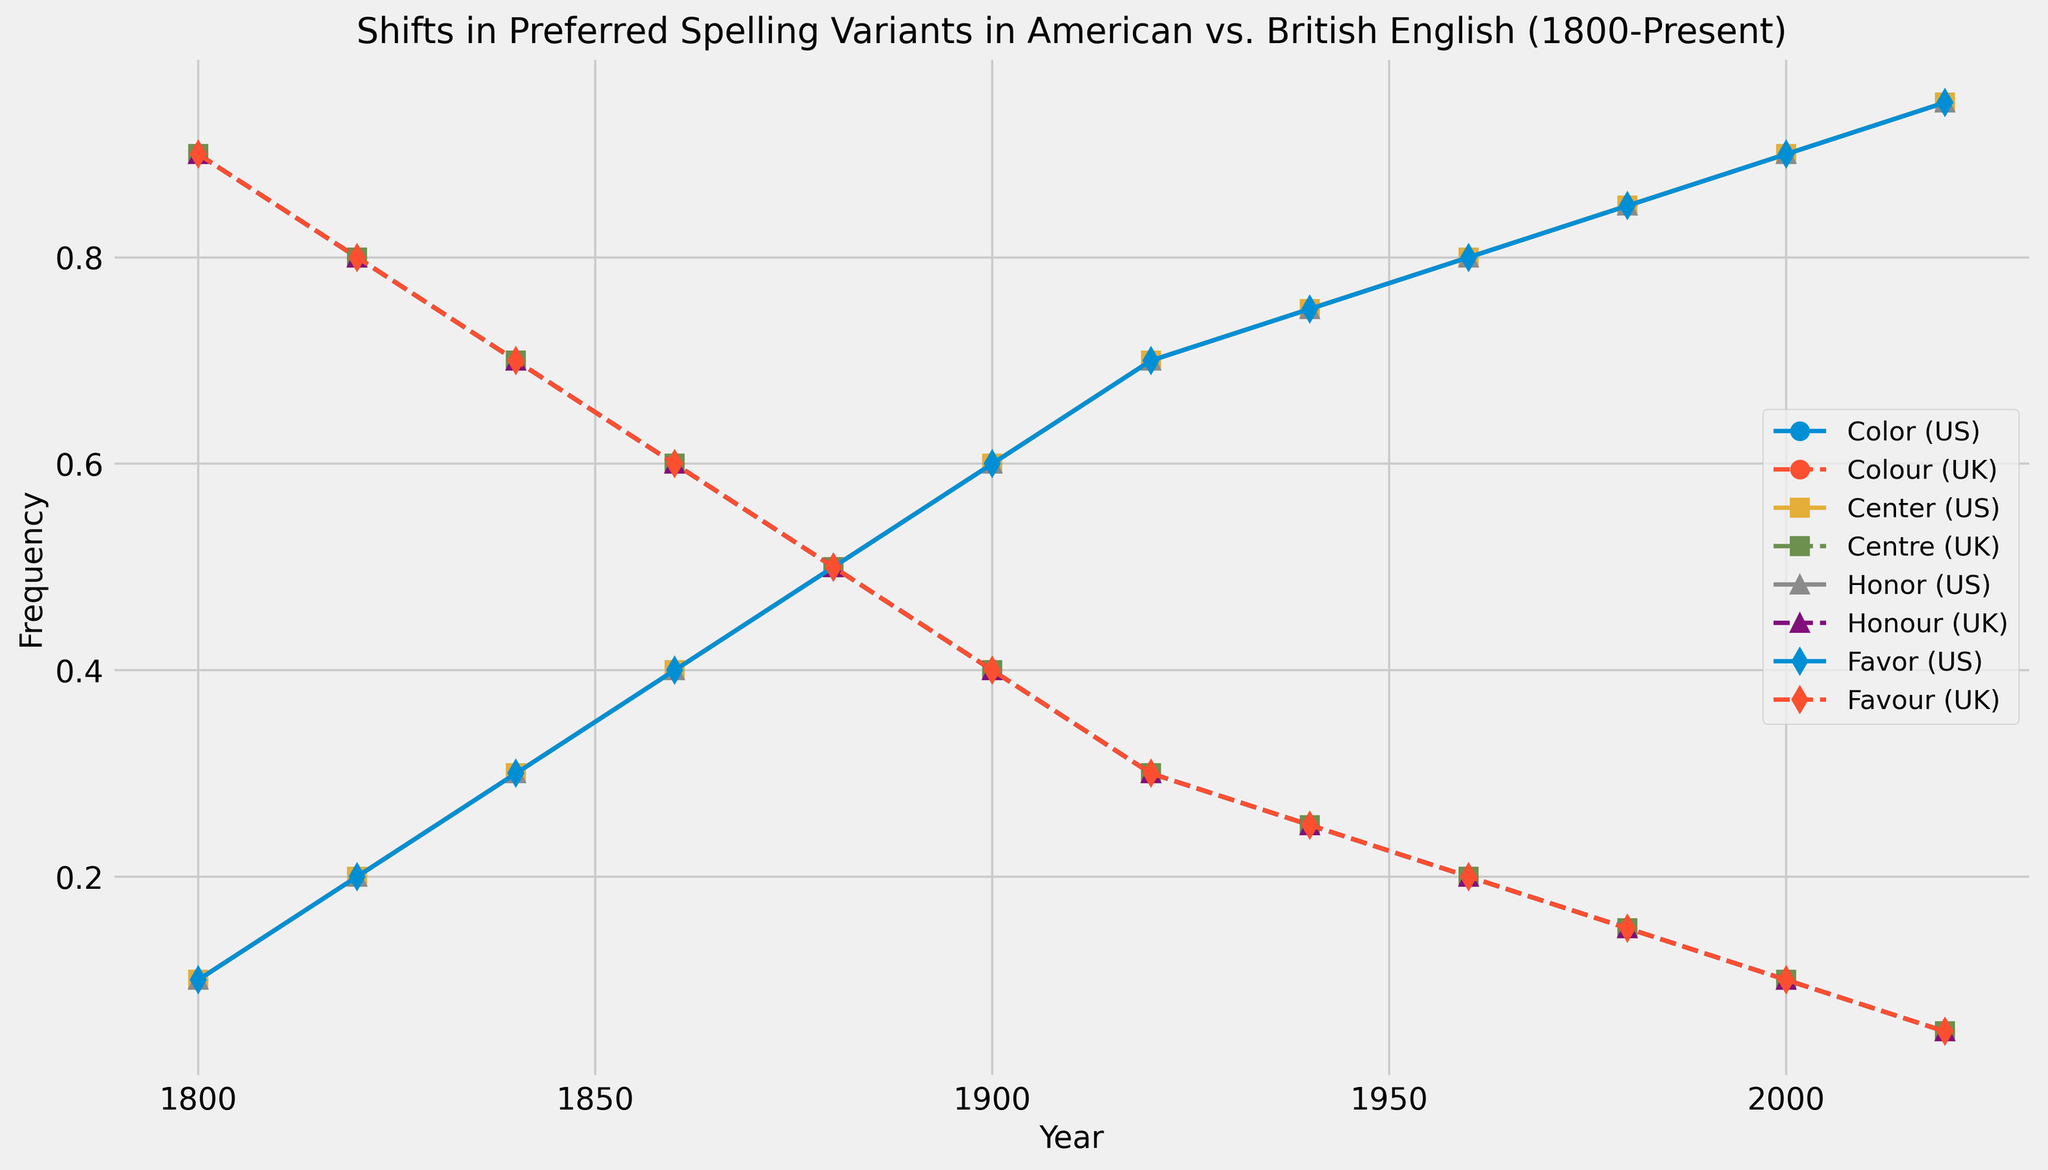what is the highest frequency of the American variants between 1800 and 1820? First, observe the frequencies for American variants (Color, Center, Honor, Favor) at the years 1800 and 1820. In 1800, the highest value is 0.1. In 1820, the highest value is 0.2. Compare these values to find the highest frequency.
Answer: 0.2 What is the difference in frequency between 'Color (US)' and 'Colour (UK)' in 1900? Look at the values for 'Color (US)' and 'Colour (UK)' in 1900. 'Color (US)' is 0.6 and 'Colour (UK)' is 0.4. Subtract 0.4 from 0.6.
Answer: 0.2 Which variant has the highest frequency in 2020? Check the frequencies of all variants in 2020. The value for all American variants is 0.95, which is higher than the value for all British variants at 0.05. Therefore, any American variant wins.
Answer: Color (US) How has the frequency of 'Centre (UK)' changed from 1860 to 1880? Look at the values for 'Centre (UK)' in 1860 (0.6) and 1880 (0.5). Subtract the 1880 value from the 1860 value: 0.6 - 0.5.
Answer: -0.1 What is the average frequency of the American spelling variants in 2000? Sum the values of the American variants in 2000 (0.9 for Color, Center, Honor, and Favor) and divide by the number of variants (4): (0.9 + 0.9 + 0.9 + 0.9) / 4.
Answer: 0.9 Between 1800 and 2020, which spelling variants show a steady increase in their frequency? Observe the trends for each spelling variant. The American variants (Color, Center, Honor, and Favor) all show a steady increase, while the British variants show a steady decrease.
Answer: Color (US), Center (US), Honor (US), Favor (US) How does the frequency difference between US and UK variants in 1920 compare to 1940 for 'Color'/'Colour'? Calculate the frequency differences in 1920 (0.7 - 0.3 = 0.4) and 1940 (0.75 - 0.25 = 0.5). Compare these differences: 0.4 in 1920 vs. 0.5 in 1940.
Answer: 0.1 greater in 1940 What is the overall trend for 'Honor (US)' from 1800 to 2020? Observe the plot for 'Honor (US)' from 1800 (0.1) to 2020 (0.95). Note that its frequency consistently increases over this period.
Answer: Increasing Which spelling variant shows a decline from 1840 to 1860? Identify any variant with a decrease in frequency between 1840 and 1860. 'Colour (UK)', 'Centre (UK)', 'Honour (UK)', and 'Favour (UK)' all decline from 0.7 to 0.6.
Answer: Colour (UK), Centre (UK), Honour (UK), Favour (UK) 